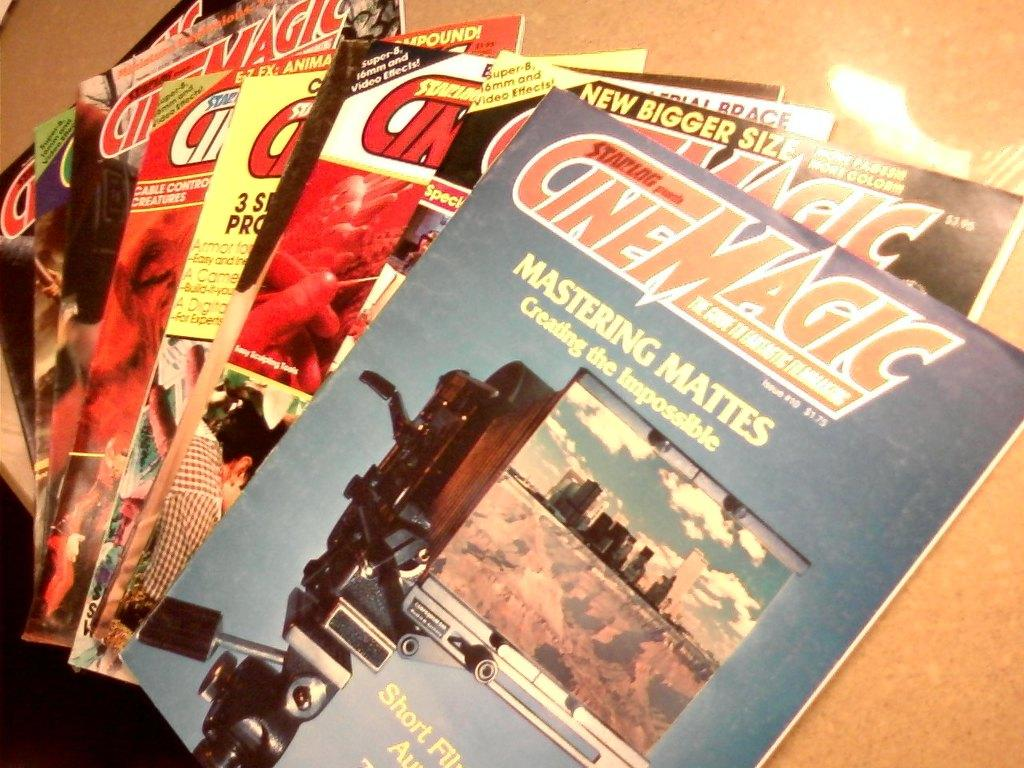Provide a one-sentence caption for the provided image. Magazines from the publisher Cinemagic are stacked on a table. 